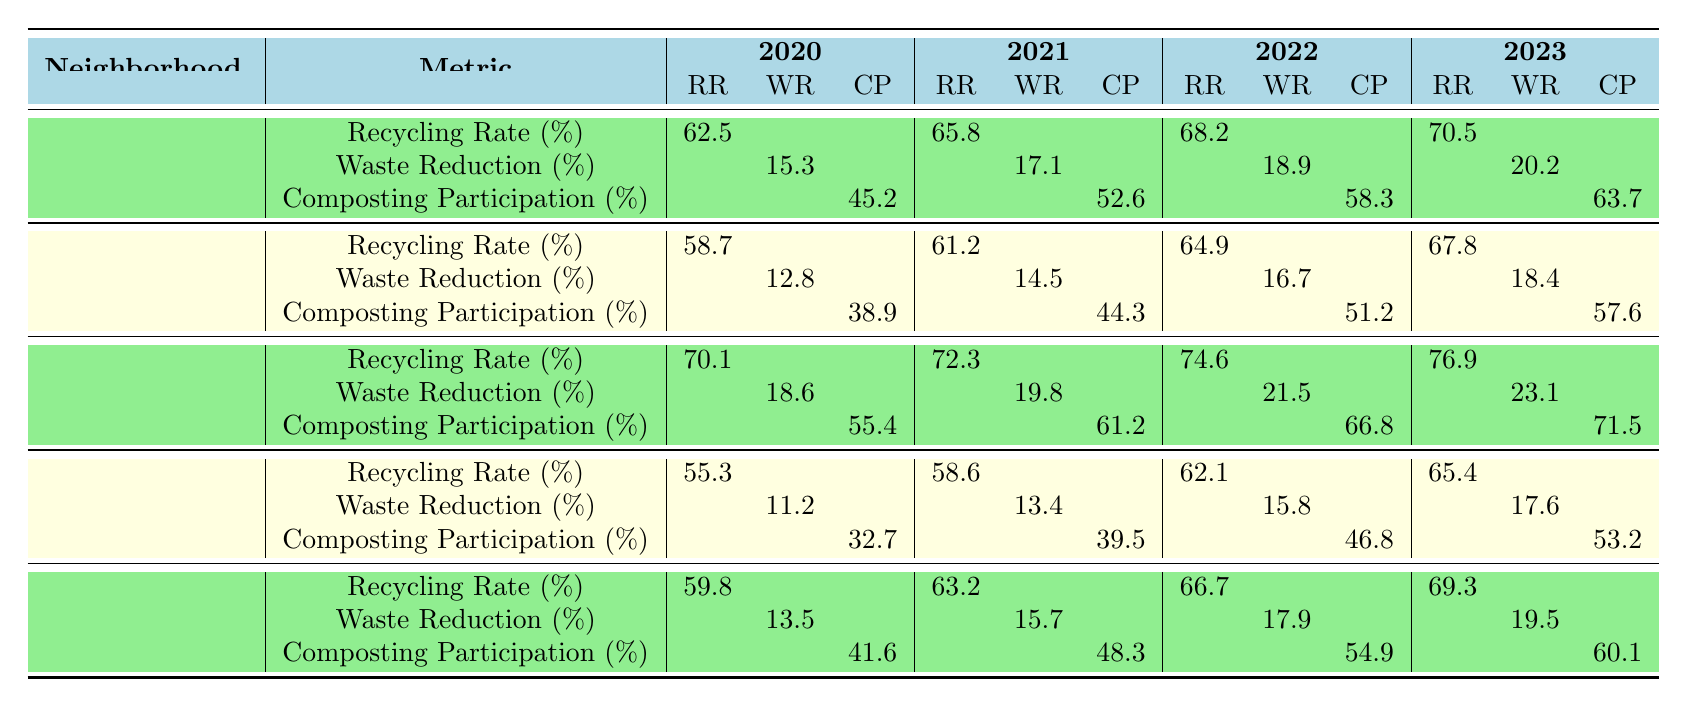What was the recycling rate in Downtown for the year 2022? The table shows the recycling rate for Downtown in 2022 is listed directly. According to the data, it is 68.2%.
Answer: 68.2% Which neighborhood had the highest composting participation in 2023? Reviewing the table, the composting participation in 2023 is highest in College Hill with a value of 71.5%.
Answer: College Hill What is the percentage increase in recycling rate from 2020 to 2023 in Meadow? The recycling rate for Meadow in 2020 is 58.7% and in 2023 is 67.8%. The increase is calculated as (67.8 - 58.7) = 9.1%.
Answer: 9.1% Did Elm Street's waste reduction percentage meet or exceed 18% in 2023? The table shows that Elm Street's waste reduction percentage in 2023 is 17.6%, which is below 18%.
Answer: No Calculate the average recycling rate across all neighborhoods for 2021. The recycling rates for all neighborhoods in 2021 are: 65.8% (Downtown), 61.2% (Meadow), 72.3% (College Hill), 58.6% (Elm Street), and 63.2% (Northfield Street). The total is (65.8 + 61.2 + 72.3 + 58.6 + 63.2) = 321.1, and dividing by 5 gives an average of 64.22%.
Answer: 64.22% Which neighborhood showed the highest waste reduction percentage in 2023 compared to 2020? The table shows the waste reduction percentages for each neighborhood in 2020 and 2023. For Downtown, it's an increase of 4.9%; Meadow, 5.6%; College Hill, 4.5%; Elm Street, 6.4%; and Northfield Street, 6.0%. The highest increase is from Elm Street, where the percentage increased from 11.2% to 17.6%.
Answer: Elm Street Is the composting participation in Northfield Street greater than 45% in 2022? The table shows Northfield Street's composting participation in 2022 is 54.9%, which is indeed greater than 45%.
Answer: Yes What was the total waste reduction percentage for College Hill between 2020 and 2023? The waste reduction percentages for College Hill from 2020 to 2023 are as follows: 18.6% (2020), 19.8% (2021), 21.5% (2022), and 23.1% (2023). Adding these values gives a total of 83% (18.6 + 19.8 + 21.5 + 23.1).
Answer: 83% Which neighborhood had the lowest recycling rate in 2020? Looking at the table, the recycling rates for 2020 show that Elm Street had the lowest with a rate of 55.3%.
Answer: Elm Street How much did composting participation increase from 2020 to 2023 for Downtown? The composting participation for Downtown in 2020 was 45.2%, and in 2023 it rose to 63.7%. The increase is (63.7 - 45.2) = 18.5%.
Answer: 18.5% 